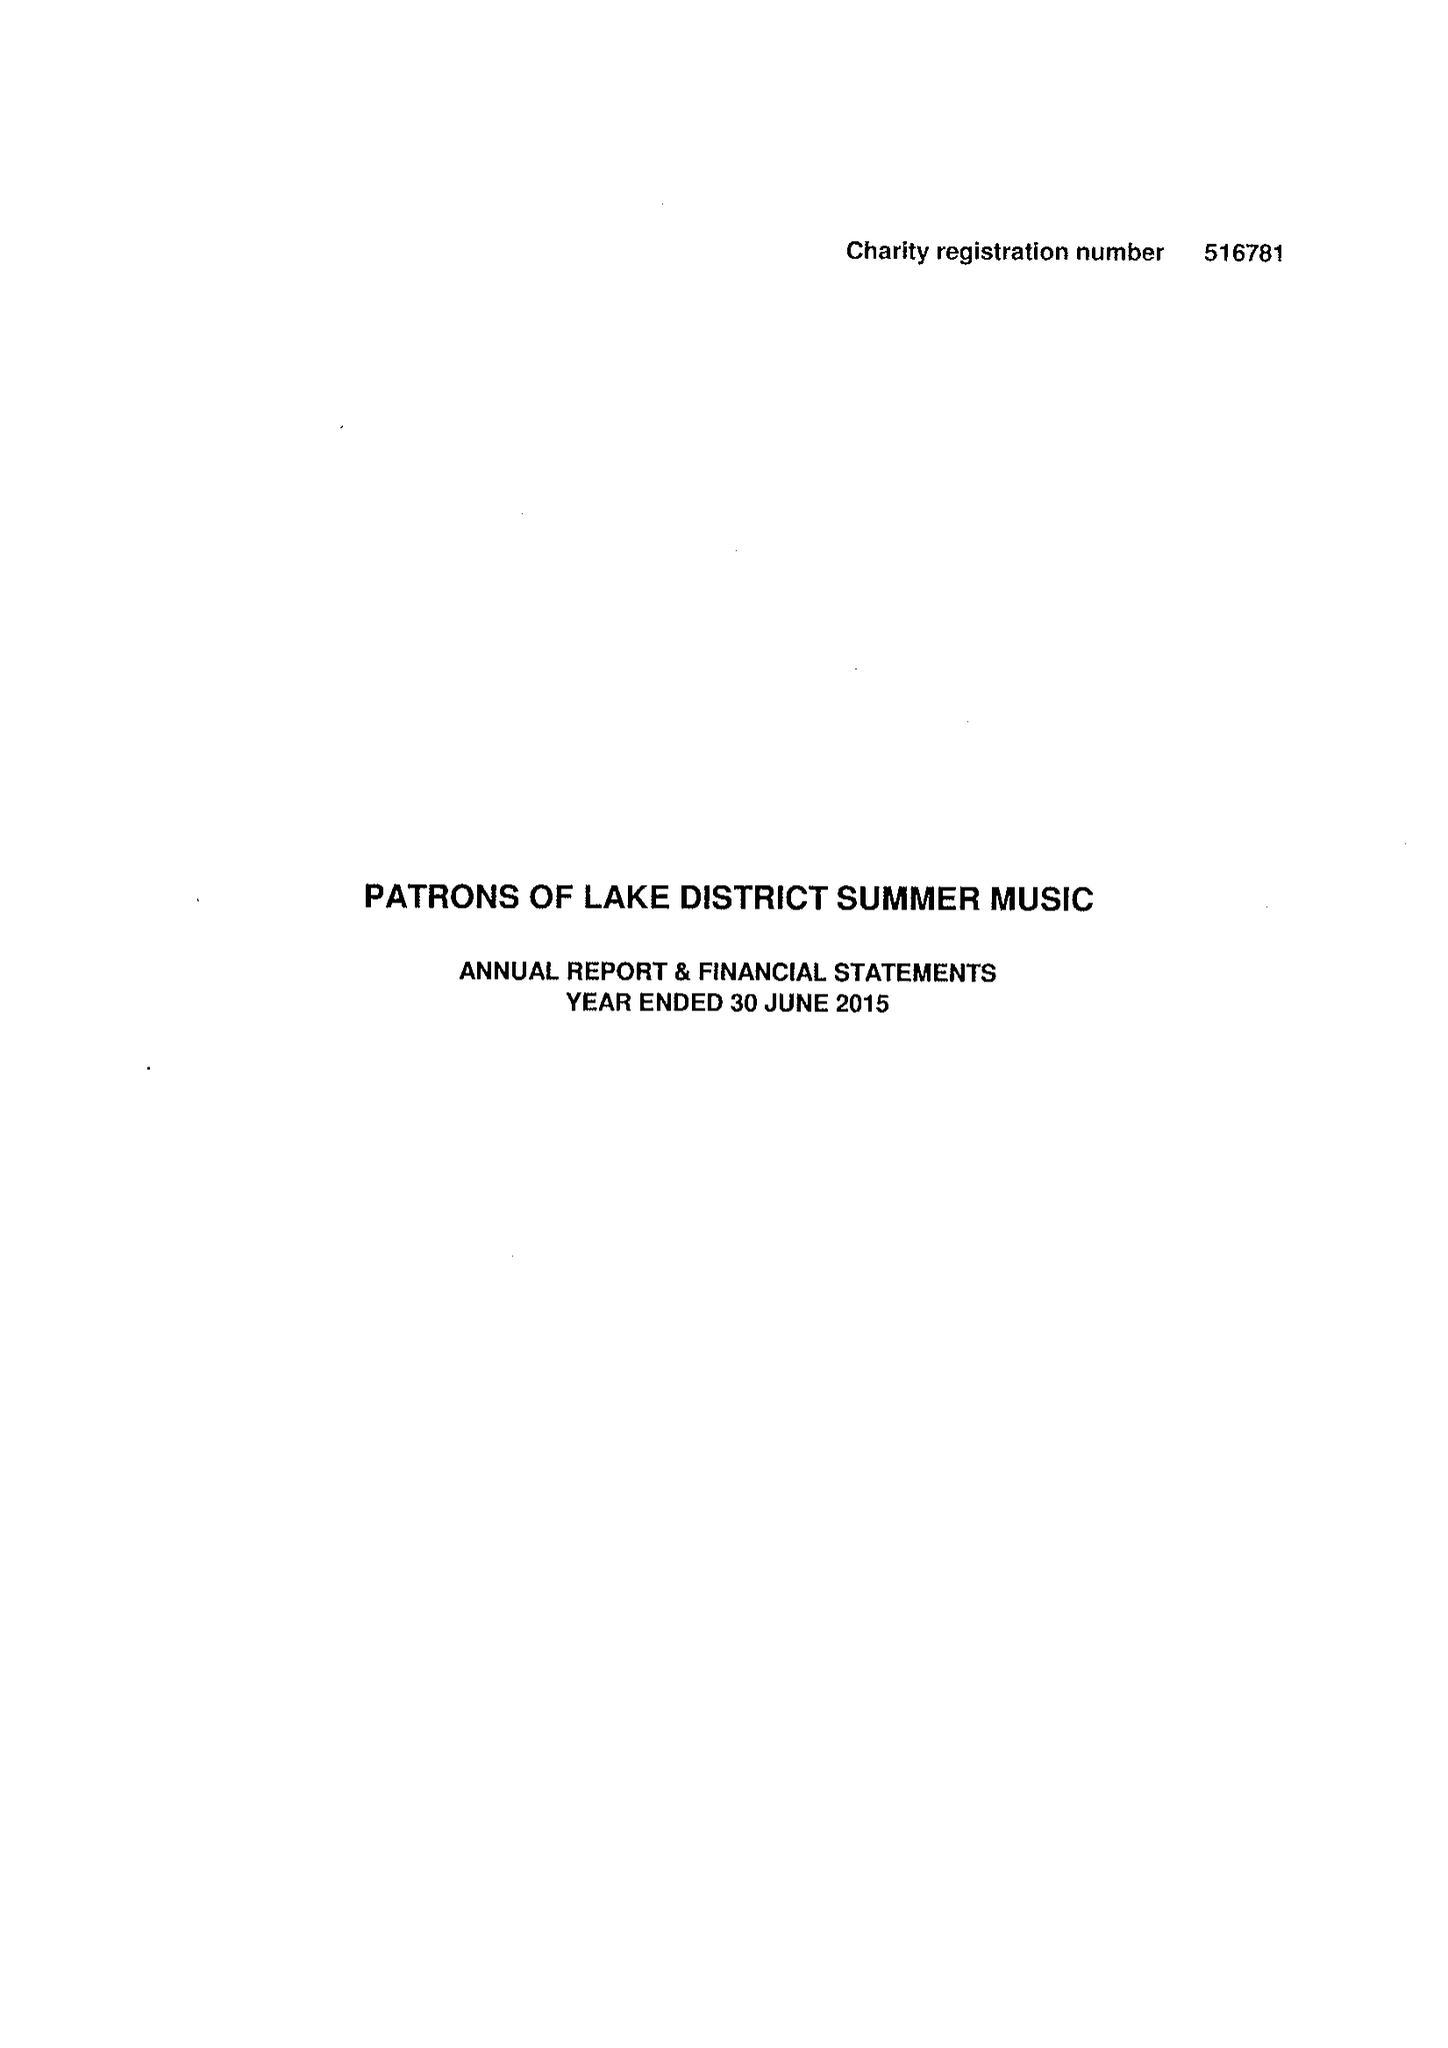What is the value for the report_date?
Answer the question using a single word or phrase. 2015-06-30 